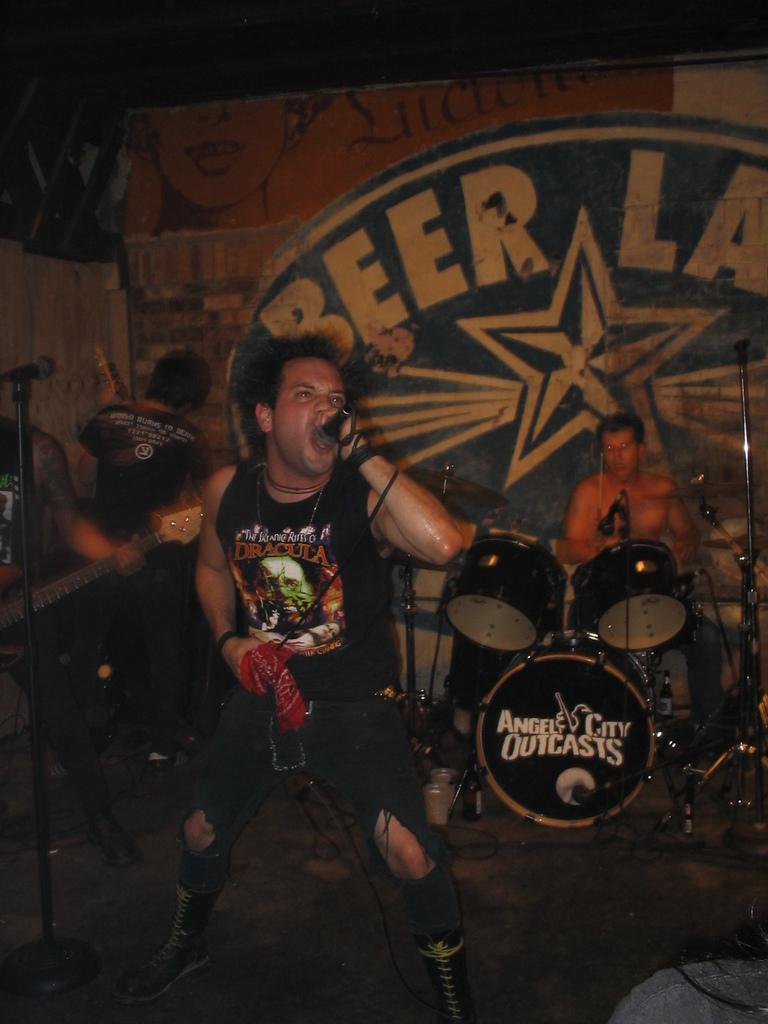What is the man on the stage doing? The man is standing on a stage and singing. What is the man holding while singing? The man is holding a microphone. What are the other people behind the man doing? The other people are playing musical instruments. What type of poison is being sprayed by the wind in the image? There is no poison or wind present in the image. What kind of patch can be seen on the man's clothing in the image? There is no patch visible on the man's clothing in the image. 